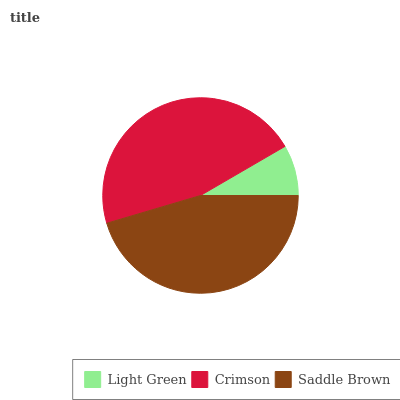Is Light Green the minimum?
Answer yes or no. Yes. Is Crimson the maximum?
Answer yes or no. Yes. Is Saddle Brown the minimum?
Answer yes or no. No. Is Saddle Brown the maximum?
Answer yes or no. No. Is Crimson greater than Saddle Brown?
Answer yes or no. Yes. Is Saddle Brown less than Crimson?
Answer yes or no. Yes. Is Saddle Brown greater than Crimson?
Answer yes or no. No. Is Crimson less than Saddle Brown?
Answer yes or no. No. Is Saddle Brown the high median?
Answer yes or no. Yes. Is Saddle Brown the low median?
Answer yes or no. Yes. Is Crimson the high median?
Answer yes or no. No. Is Light Green the low median?
Answer yes or no. No. 